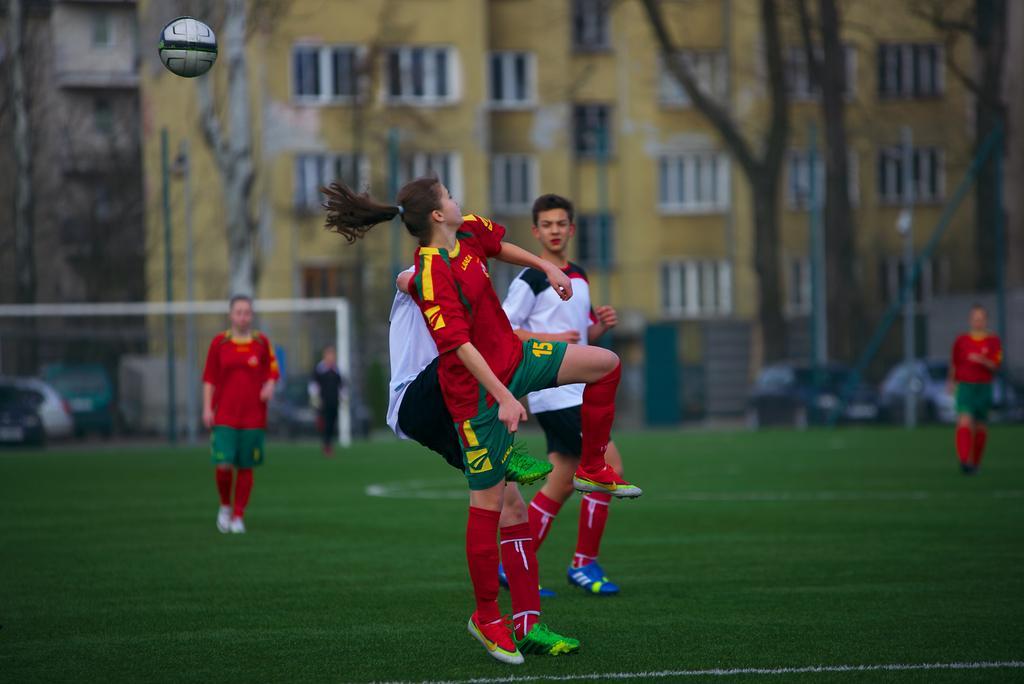In one or two sentences, can you explain what this image depicts? In this image in the foreground there are some people, and they are wearing jersey it seems that they are playing something. And there is one ball which is in air, at the bottom there is ground. In the background there are some buildings, not, trees, vehicles and some people. 